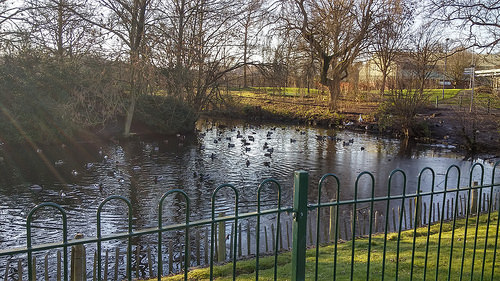<image>
Is there a fence on the lake? No. The fence is not positioned on the lake. They may be near each other, but the fence is not supported by or resting on top of the lake. 